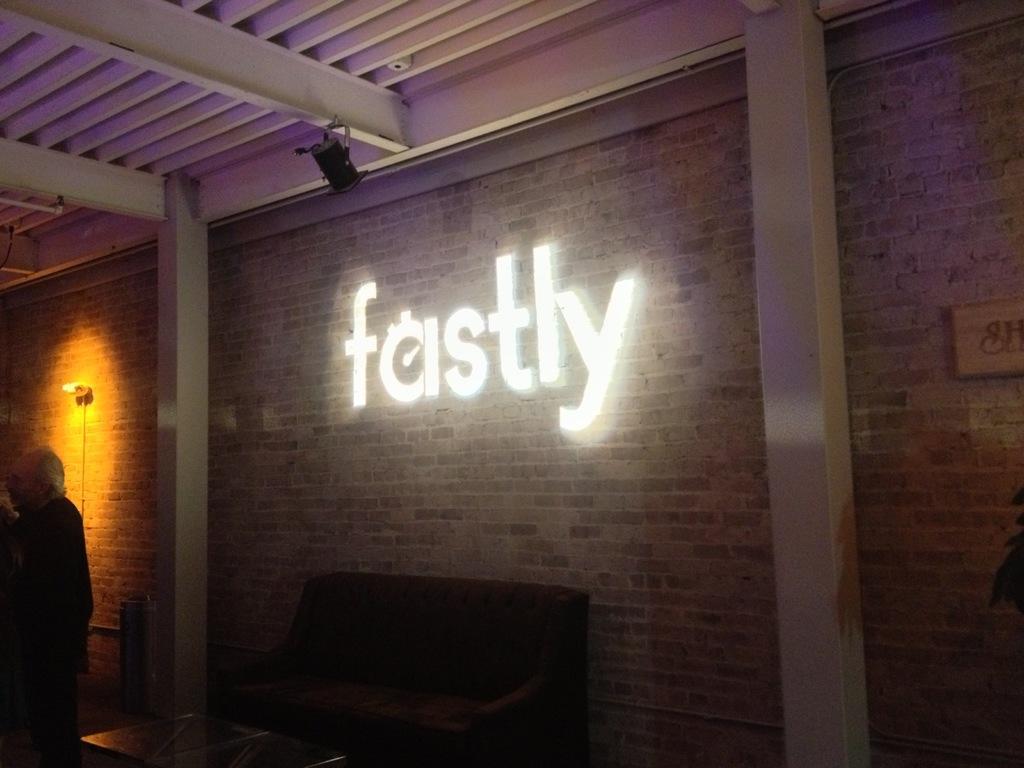In one or two sentences, can you explain what this image depicts? This picture is of inside. In the center we can see a couch and a table. On the left there is a man standing. In the background we can see a brick wall and a text with lights. 